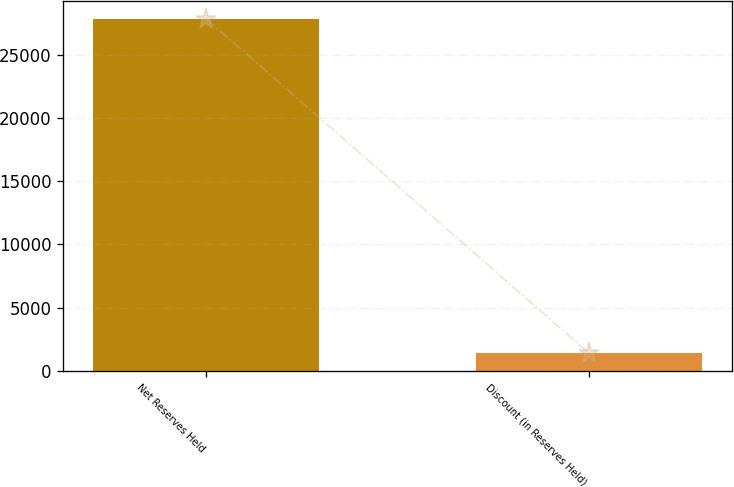Convert chart to OTSL. <chart><loc_0><loc_0><loc_500><loc_500><bar_chart><fcel>Net Reserves Held<fcel>Discount (in Reserves Held)<nl><fcel>27814.6<fcel>1423<nl></chart> 